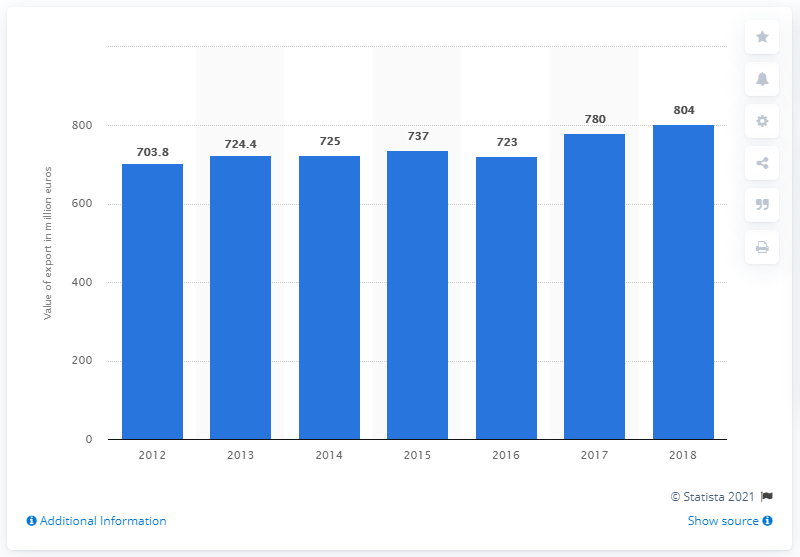Point out several critical features in this image. In 2018, the total value of wine exported from Portugal was 804 million euros. 